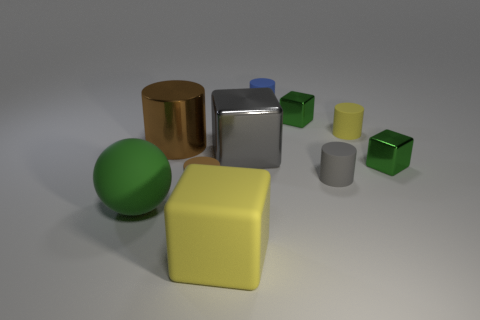What materials do the objects in the image appear to be made of? The objects in the image seem to have different materials. The sphere and the gold cylinder appear to have a matte finish, suggesting they could be made of a plastic or painted wood with a non-reflective coating. The silver cylinder and blue box have a reflective surface that could be indicative of metal or a polished plastic. 